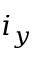<formula> <loc_0><loc_0><loc_500><loc_500>i _ { y }</formula> 